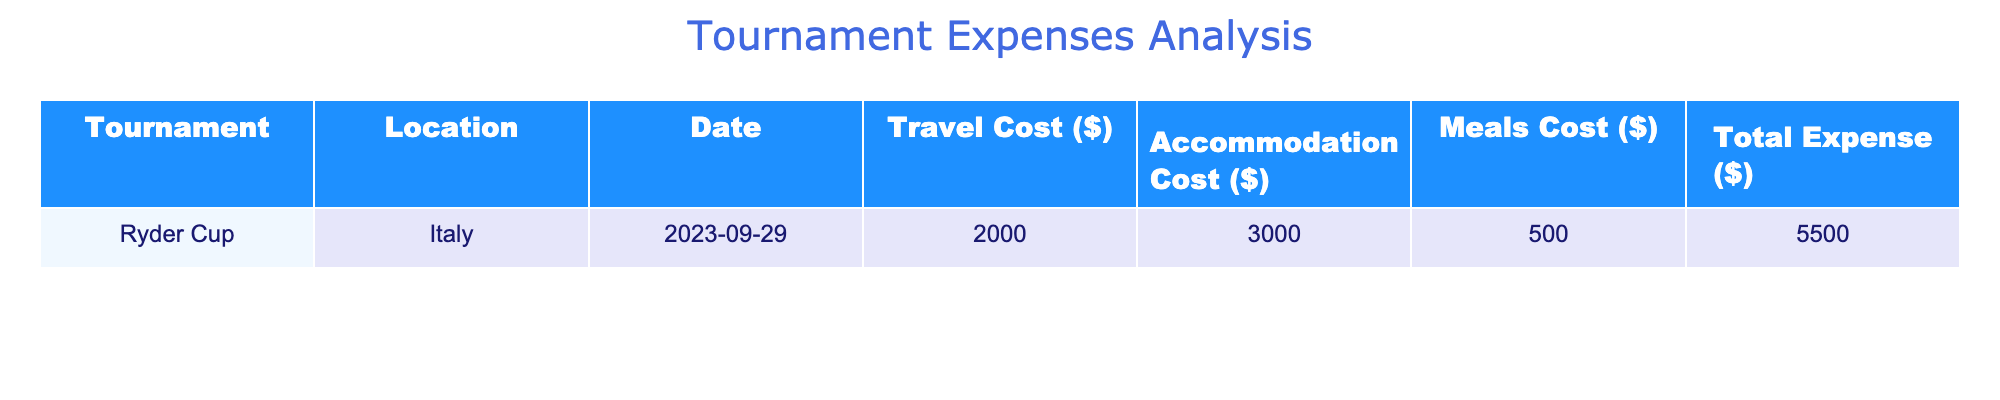What is the total expense for the Ryder Cup? The total expense is listed directly in the table under the Total Expense column for the Ryder Cup. This value is 5500.
Answer: 5500 What is the travel cost for the Ryder Cup? The travel cost can be found in the Travel Cost column corresponding to the Ryder Cup tournament. The listed value is 2000.
Answer: 2000 What is the sum of the accommodation cost and meals cost for the Ryder Cup? The accommodation cost is 3000 and the meals cost is 500. Adding these values gives: 3000 + 500 = 3500.
Answer: 3500 Did the meals cost for the Ryder Cup exceed 600 dollars? To determine this, we look at the Meals Cost for the Ryder Cup, which is 500. Since 500 is less than 600, the answer is no.
Answer: No What is the total of travel, accommodation, and meals costs for the Ryder Cup? The total can be calculated by summing the Travel Cost (2000), Accommodation Cost (3000), and Meals Cost (500). The calculation is: 2000 + 3000 + 500 = 5500. This matches the Total Expense value, confirming the calculation.
Answer: 5500 What was the accommodation cost for the Ryder Cup? This value can be found directly in the Accommodation Cost column related to the Ryder Cup, which is 3000.
Answer: 3000 What is the average cost for travel, accommodation, and meals for the Ryder Cup? To find the average, first sum all three costs: 2000 (Travel) + 3000 (Accommodation) + 500 (Meals) = 5500. Then, divide this total by the number of categories (3): 5500 / 3 = approximately 1833.33.
Answer: 1833.33 Is the travel cost for the Ryder Cup greater than the accommodation cost? The travel cost is 2000 and the accommodation cost is 3000. Since 2000 is less than 3000, the answer is no.
Answer: No What was the location of the Ryder Cup? This information is found in the Location column for the Ryder Cup tournament, which is Italy.
Answer: Italy 